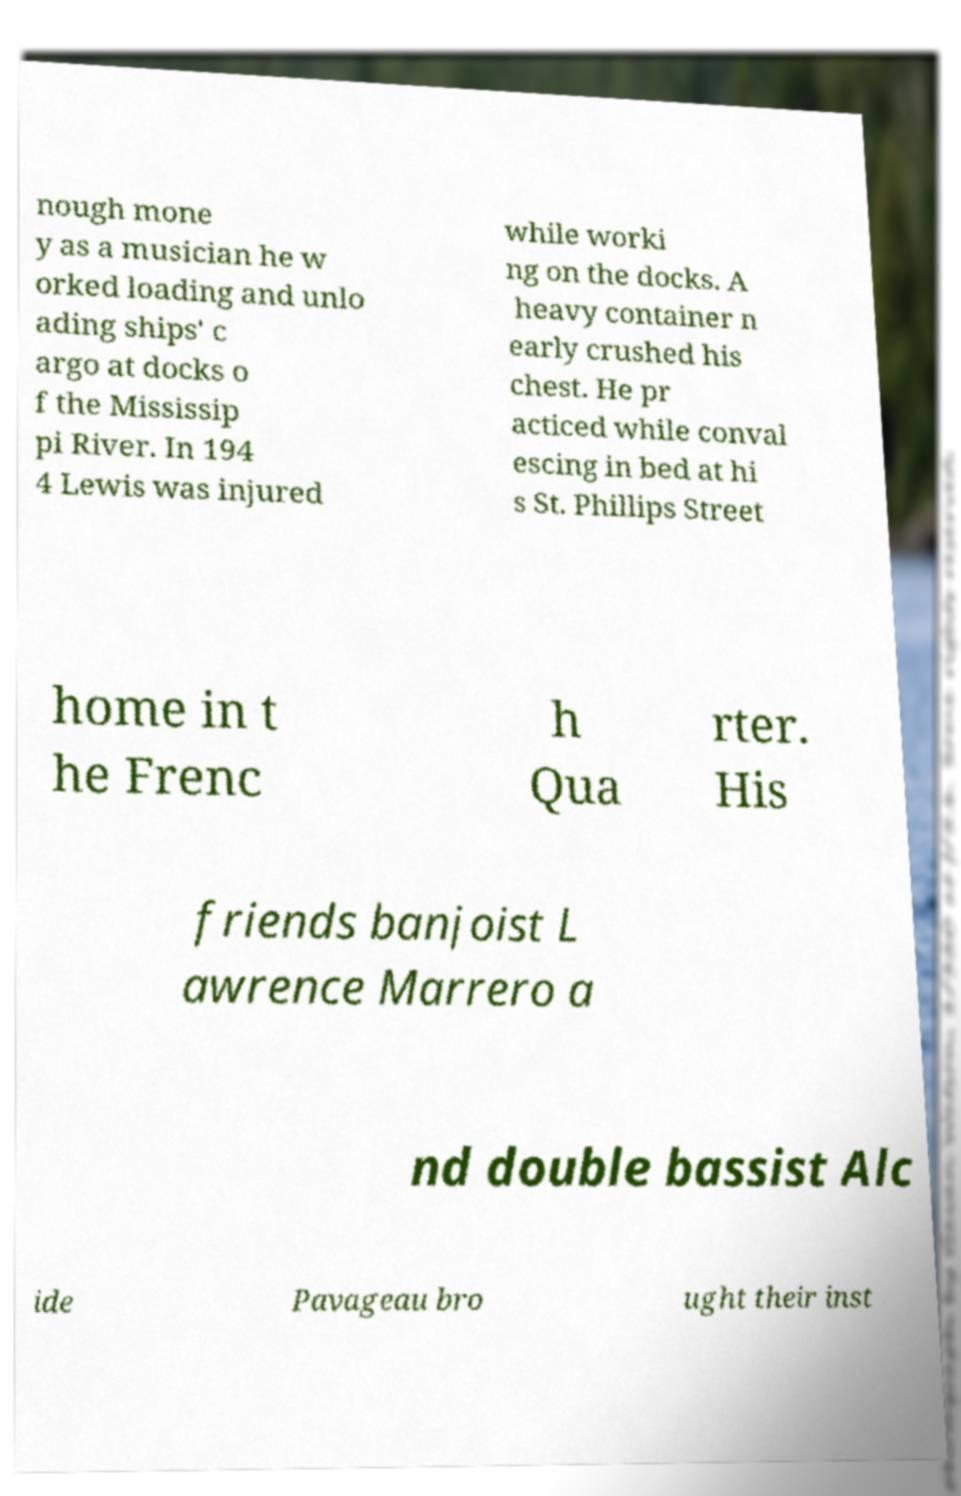I need the written content from this picture converted into text. Can you do that? nough mone y as a musician he w orked loading and unlo ading ships' c argo at docks o f the Mississip pi River. In 194 4 Lewis was injured while worki ng on the docks. A heavy container n early crushed his chest. He pr acticed while conval escing in bed at hi s St. Phillips Street home in t he Frenc h Qua rter. His friends banjoist L awrence Marrero a nd double bassist Alc ide Pavageau bro ught their inst 